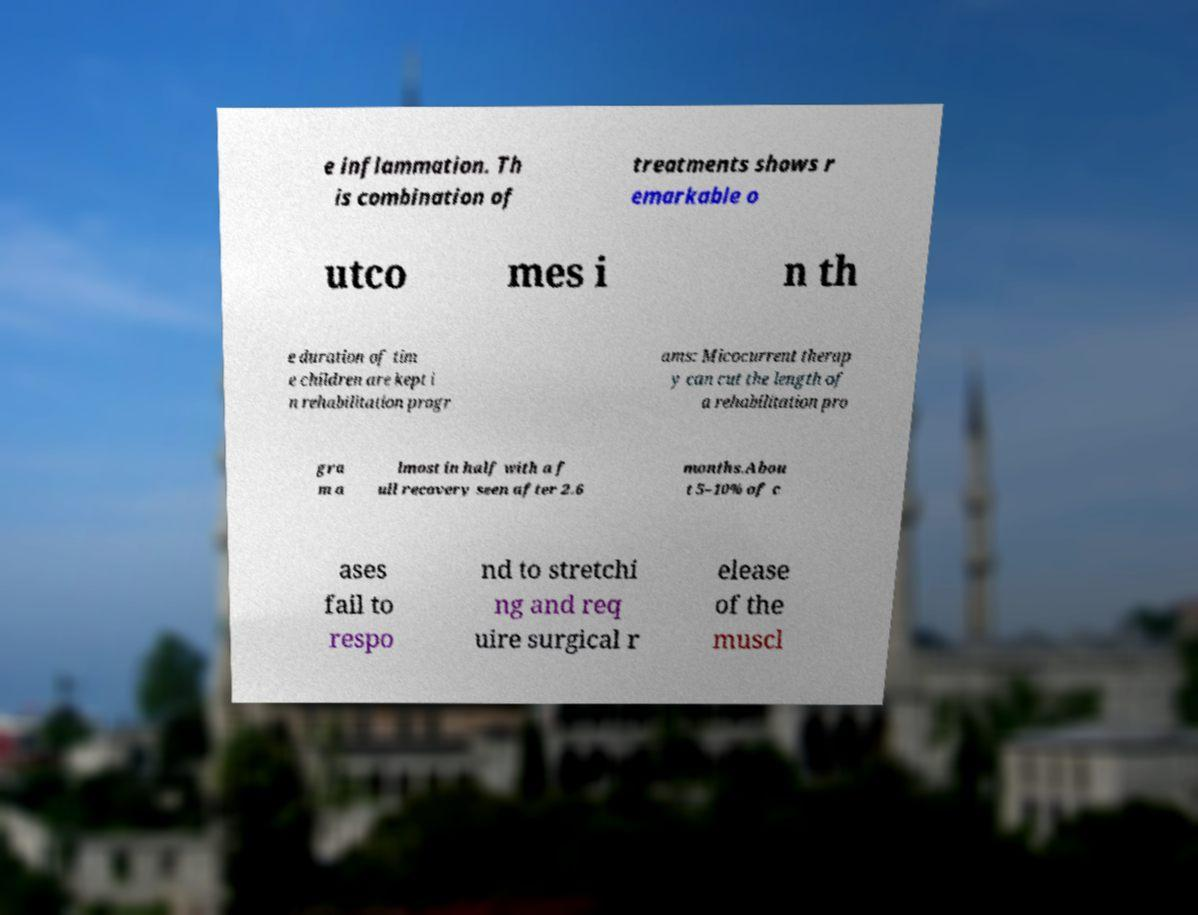I need the written content from this picture converted into text. Can you do that? e inflammation. Th is combination of treatments shows r emarkable o utco mes i n th e duration of tim e children are kept i n rehabilitation progr ams: Micocurrent therap y can cut the length of a rehabilitation pro gra m a lmost in half with a f ull recovery seen after 2.6 months.Abou t 5–10% of c ases fail to respo nd to stretchi ng and req uire surgical r elease of the muscl 